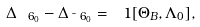<formula> <loc_0><loc_0><loc_500><loc_500>\Delta _ { \ 6 _ { 0 } } - \Delta _ { \bar { \ } 6 _ { 0 } } = \ 1 [ \Theta _ { B } , \Lambda _ { 0 } ] ,</formula> 